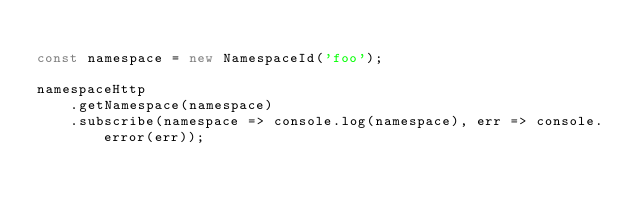<code> <loc_0><loc_0><loc_500><loc_500><_JavaScript_>
const namespace = new NamespaceId('foo');

namespaceHttp
    .getNamespace(namespace)
    .subscribe(namespace => console.log(namespace), err => console.error(err));</code> 